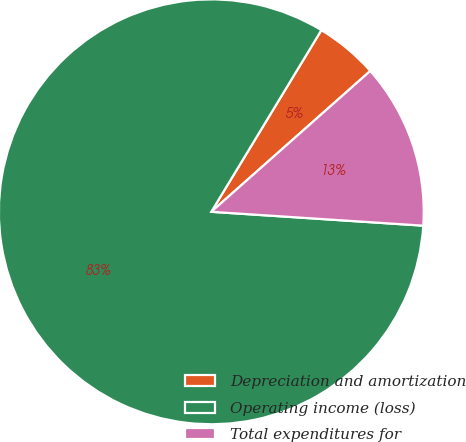<chart> <loc_0><loc_0><loc_500><loc_500><pie_chart><fcel>Depreciation and amortization<fcel>Operating income (loss)<fcel>Total expenditures for<nl><fcel>4.79%<fcel>82.63%<fcel>12.58%<nl></chart> 